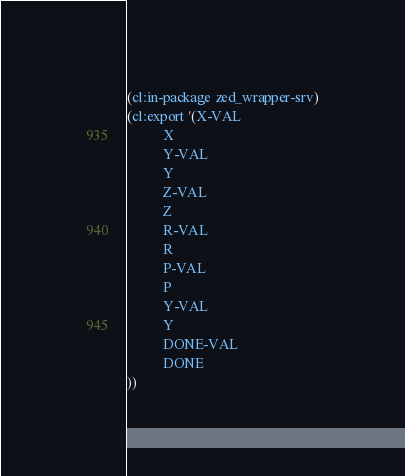<code> <loc_0><loc_0><loc_500><loc_500><_Lisp_>(cl:in-package zed_wrapper-srv)
(cl:export '(X-VAL
          X
          Y-VAL
          Y
          Z-VAL
          Z
          R-VAL
          R
          P-VAL
          P
          Y-VAL
          Y
          DONE-VAL
          DONE
))</code> 